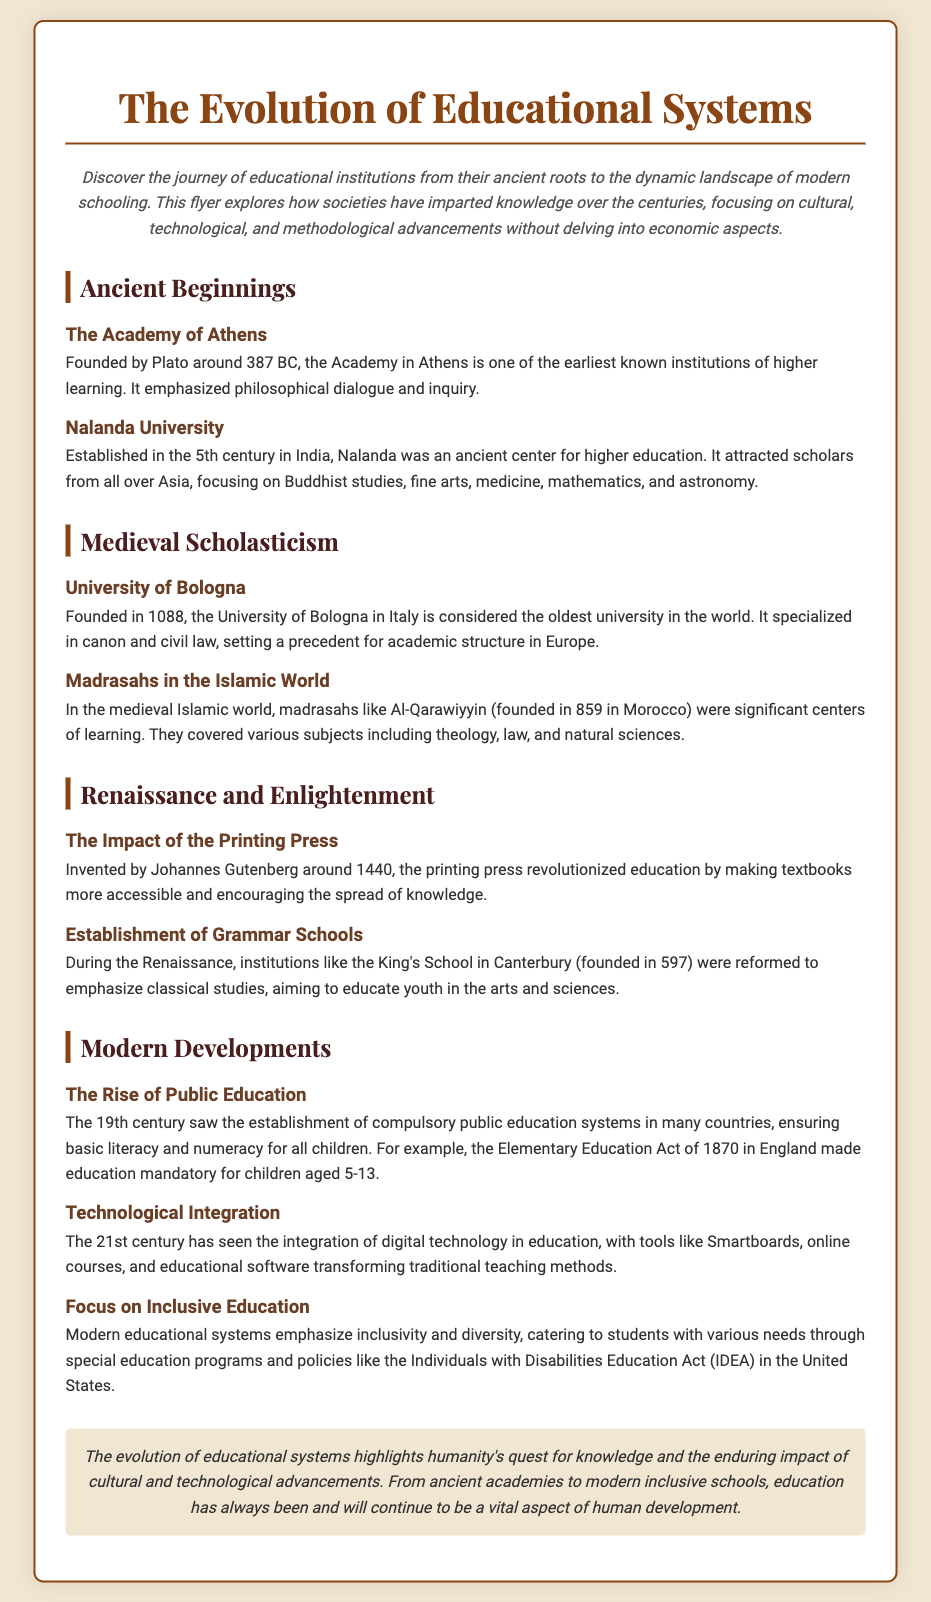What year was the Academy of Athens founded? The document states that the Academy of Athens was founded around 387 BC.
Answer: 387 BC Who founded Nalanda University? The document mentions that Nalanda University was established in the 5th century and is a center for higher education.
Answer: Not specified What was the focus of the University of Bologna? According to the document, the University of Bologna specialized in canon and civil law.
Answer: Canon and civil law In what century did public education systems begin to establish? The document indicates that the 19th century saw the establishment of compulsory public education systems.
Answer: 19th century What invention revolutionized education during the Renaissance? The document states that the printing press invented by Johannes Gutenberg around 1440 revolutionized education.
Answer: Printing press Which act made education mandatory for children in England? The document refers to the Elementary Education Act of 1870 as the act that made education mandatory.
Answer: Elementary Education Act of 1870 What type of schools were emphasized during the Renaissance? The document mentions that grammar schools were emphasized during the Renaissance for classical studies.
Answer: Grammar schools What contemporary issues are prioritized in modern educational systems? The document notes that modern educational systems emphasize inclusivity and diversity.
Answer: Inclusivity and diversity What impact did the printing press have on education? The document explains that the printing press made textbooks more accessible and encouraged the spread of knowledge.
Answer: More accessible textbooks 